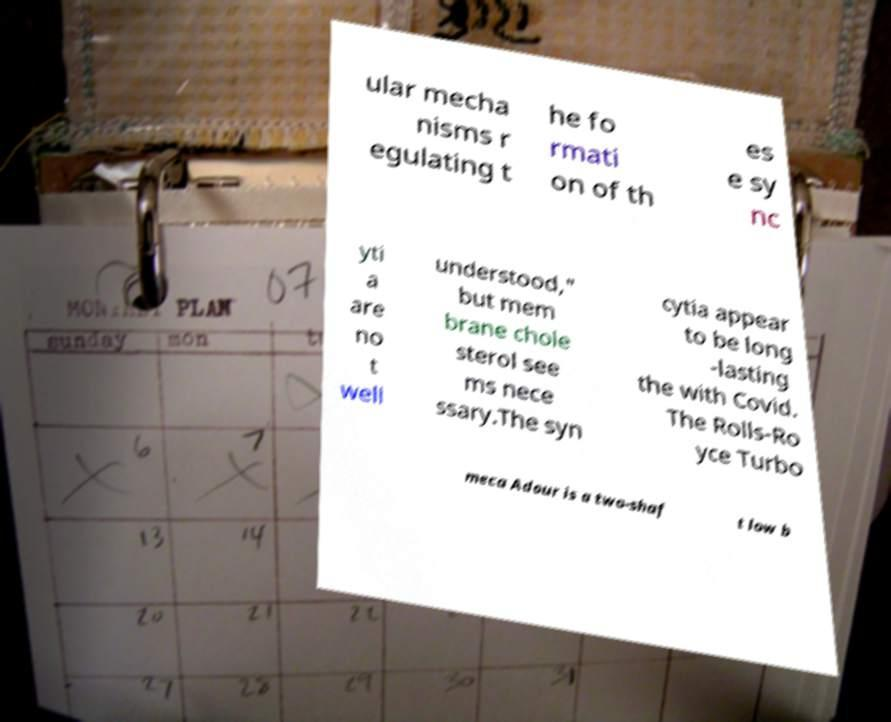What messages or text are displayed in this image? I need them in a readable, typed format. ular mecha nisms r egulating t he fo rmati on of th es e sy nc yti a are no t well understood," but mem brane chole sterol see ms nece ssary.The syn cytia appear to be long -lasting the with Covid. The Rolls-Ro yce Turbo meca Adour is a two-shaf t low b 